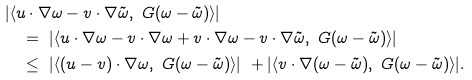Convert formula to latex. <formula><loc_0><loc_0><loc_500><loc_500>& | \langle u \cdot \nabla \omega - v \cdot \nabla \tilde { \omega } , \ G ( \omega - \tilde { \omega } ) \rangle | \\ & \quad = \ | \langle u \cdot \nabla \omega - v \cdot \nabla \omega + v \cdot \nabla \omega - v \cdot \nabla \tilde { \omega } , \ G ( \omega - \tilde { \omega } ) \rangle | \\ & \quad \leq \ | \langle ( u - v ) \cdot \nabla \omega , \ G ( \omega - \tilde { \omega } ) \rangle | \ + | \langle v \cdot \nabla ( \omega - \tilde { \omega } ) , \ G ( \omega - \tilde { \omega } ) \rangle | .</formula> 